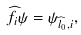Convert formula to latex. <formula><loc_0><loc_0><loc_500><loc_500>\widehat { f } _ { i } \psi = \psi _ { \widehat { l } _ { 0 } , i } ,</formula> 